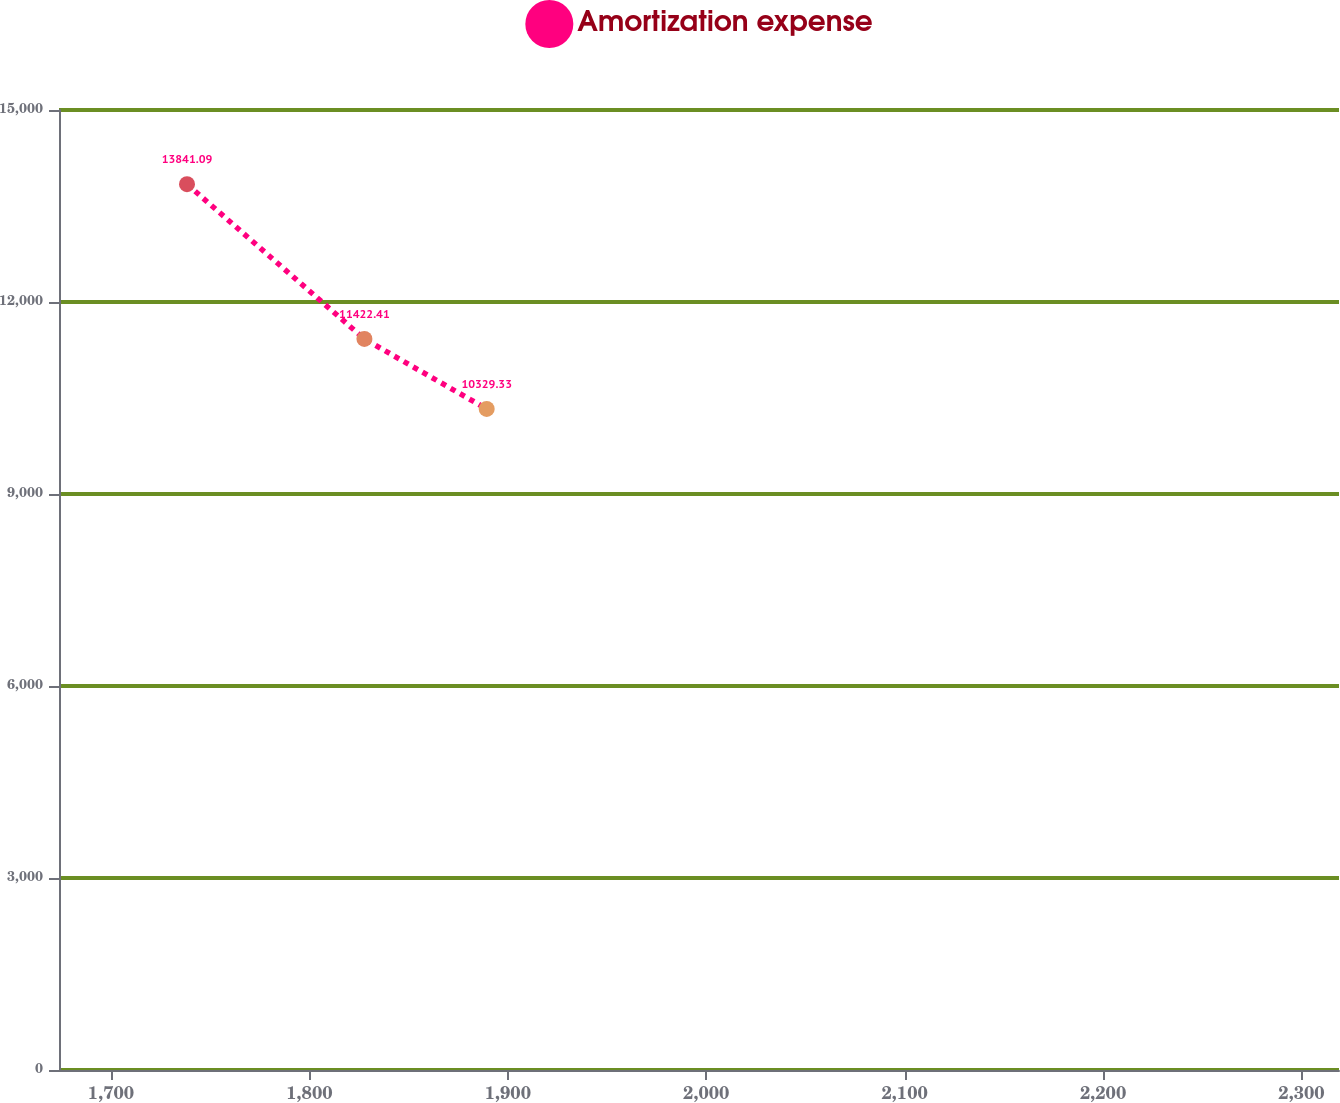<chart> <loc_0><loc_0><loc_500><loc_500><line_chart><ecel><fcel>Amortization expense<nl><fcel>1738.32<fcel>13841.1<nl><fcel>1827.73<fcel>11422.4<nl><fcel>1889.35<fcel>10329.3<nl><fcel>2321.8<fcel>7413.61<nl><fcel>2383.42<fcel>2910.31<nl></chart> 